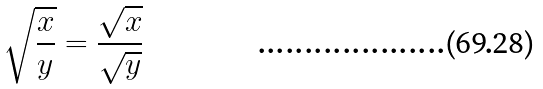Convert formula to latex. <formula><loc_0><loc_0><loc_500><loc_500>\sqrt { \frac { x } { y } } = \frac { \sqrt { x } } { \sqrt { y } }</formula> 